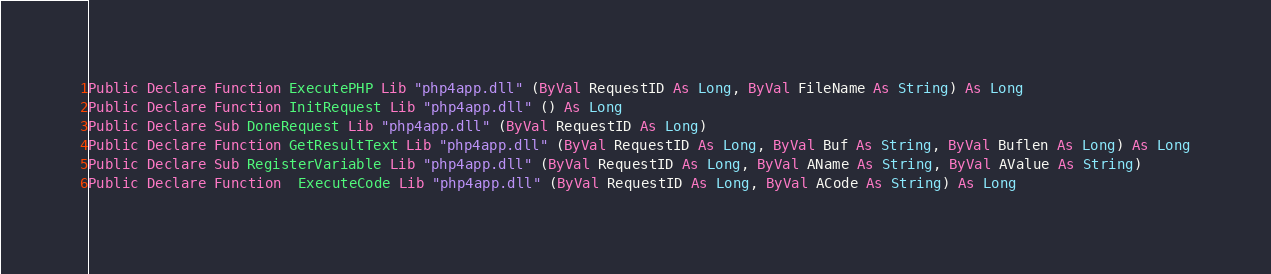Convert code to text. <code><loc_0><loc_0><loc_500><loc_500><_VisualBasic_>
Public Declare Function ExecutePHP Lib "php4app.dll" (ByVal RequestID As Long, ByVal FileName As String) As Long
Public Declare Function InitRequest Lib "php4app.dll" () As Long
Public Declare Sub DoneRequest Lib "php4app.dll" (ByVal RequestID As Long)
Public Declare Function GetResultText Lib "php4app.dll" (ByVal RequestID As Long, ByVal Buf As String, ByVal Buflen As Long) As Long
Public Declare Sub RegisterVariable Lib "php4app.dll" (ByVal RequestID As Long, ByVal AName As String, ByVal AValue As String)
Public Declare Function  ExecuteCode Lib "php4app.dll" (ByVal RequestID As Long, ByVal ACode As String) As Long</code> 